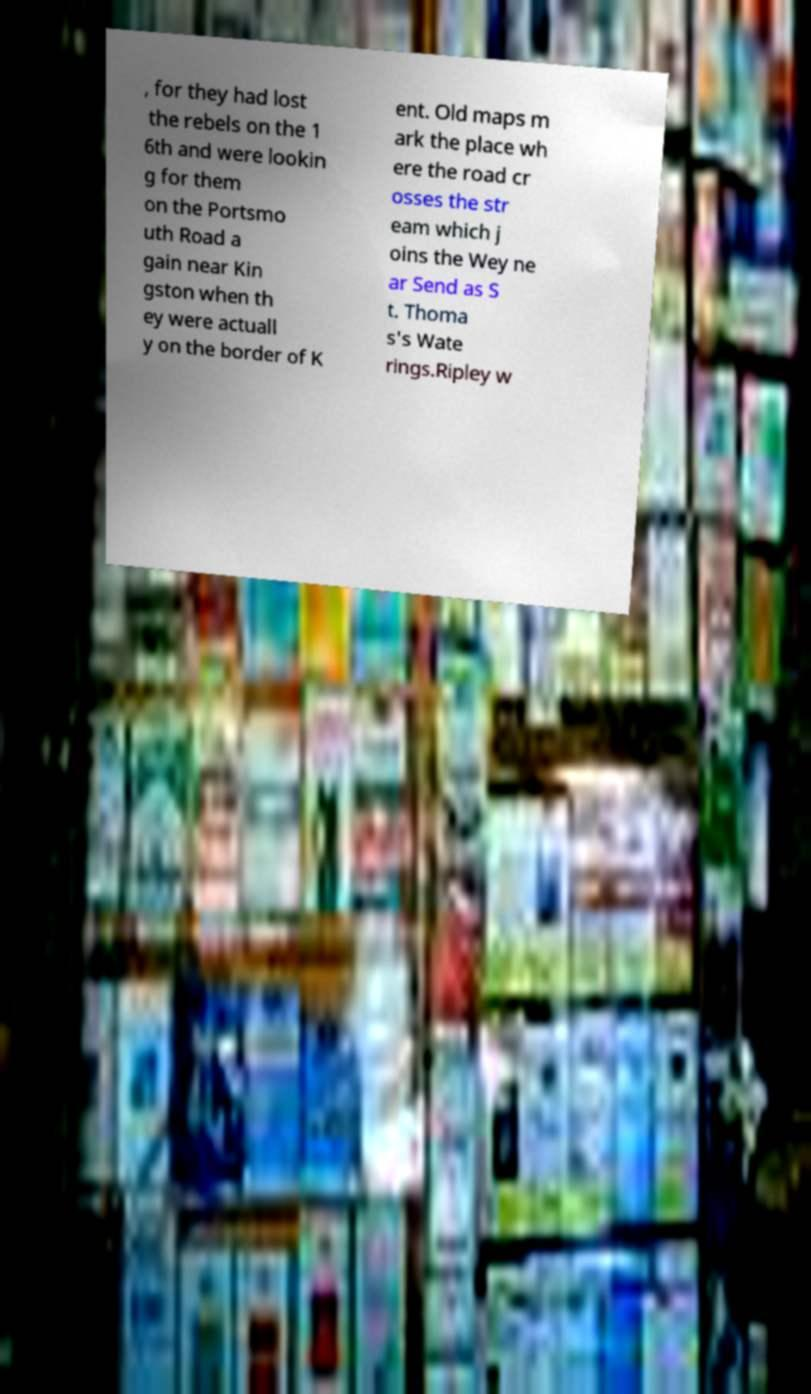I need the written content from this picture converted into text. Can you do that? , for they had lost the rebels on the 1 6th and were lookin g for them on the Portsmo uth Road a gain near Kin gston when th ey were actuall y on the border of K ent. Old maps m ark the place wh ere the road cr osses the str eam which j oins the Wey ne ar Send as S t. Thoma s's Wate rings.Ripley w 